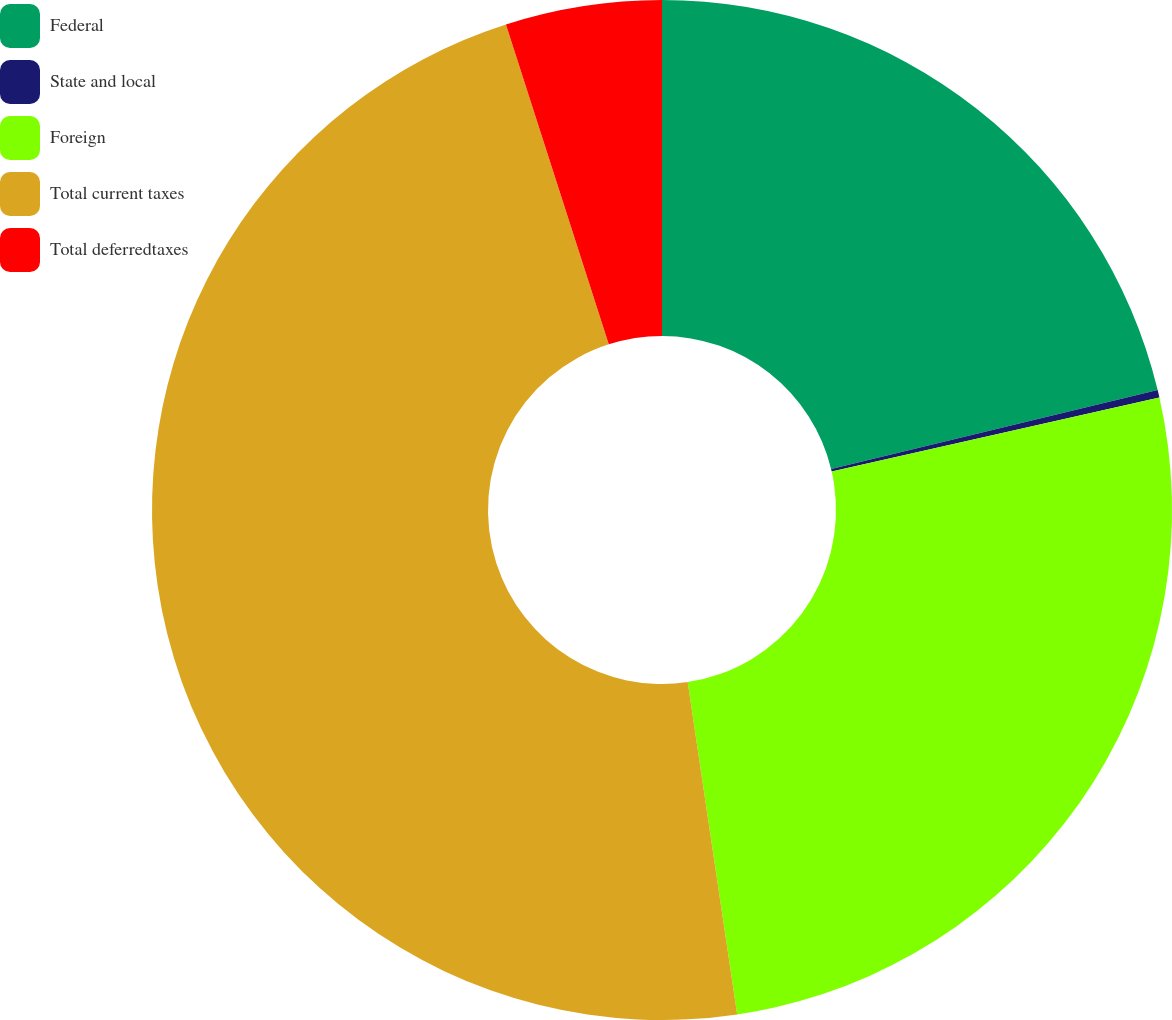<chart> <loc_0><loc_0><loc_500><loc_500><pie_chart><fcel>Federal<fcel>State and local<fcel>Foreign<fcel>Total current taxes<fcel>Total deferredtaxes<nl><fcel>21.22%<fcel>0.24%<fcel>26.19%<fcel>47.41%<fcel>4.95%<nl></chart> 